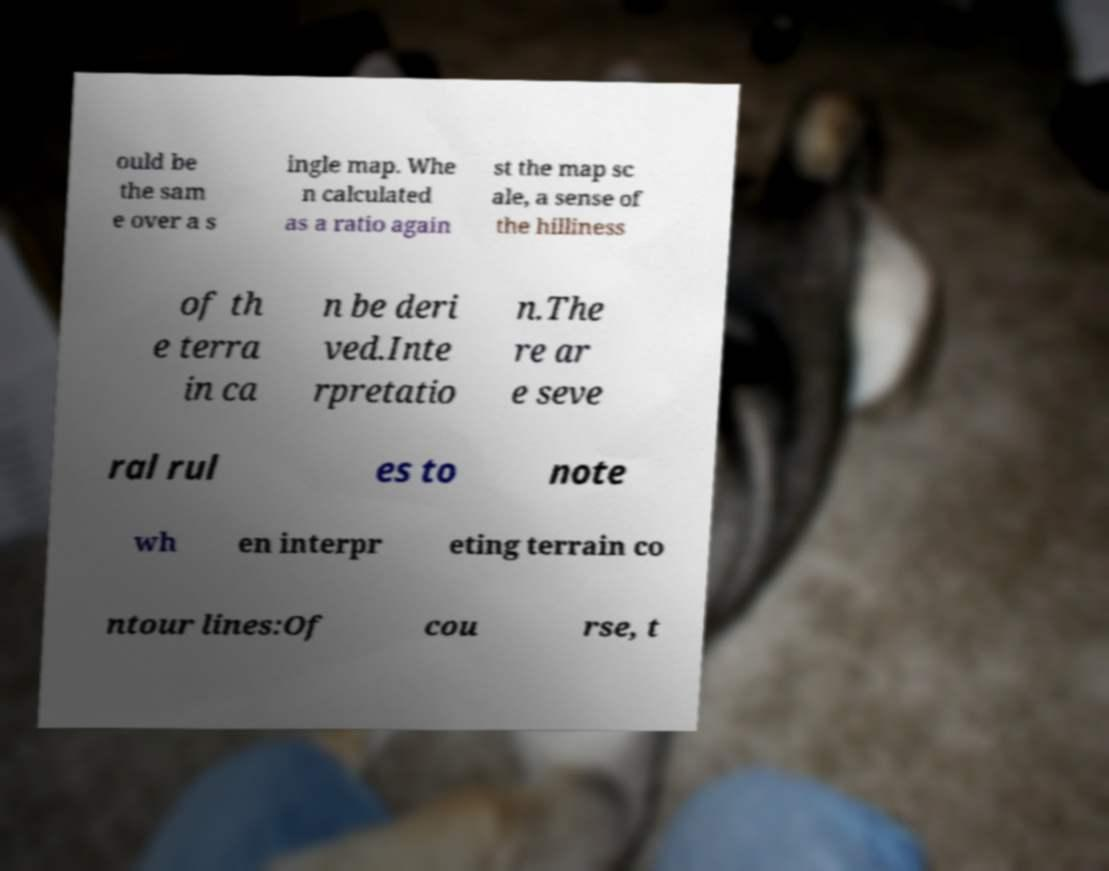There's text embedded in this image that I need extracted. Can you transcribe it verbatim? ould be the sam e over a s ingle map. Whe n calculated as a ratio again st the map sc ale, a sense of the hilliness of th e terra in ca n be deri ved.Inte rpretatio n.The re ar e seve ral rul es to note wh en interpr eting terrain co ntour lines:Of cou rse, t 